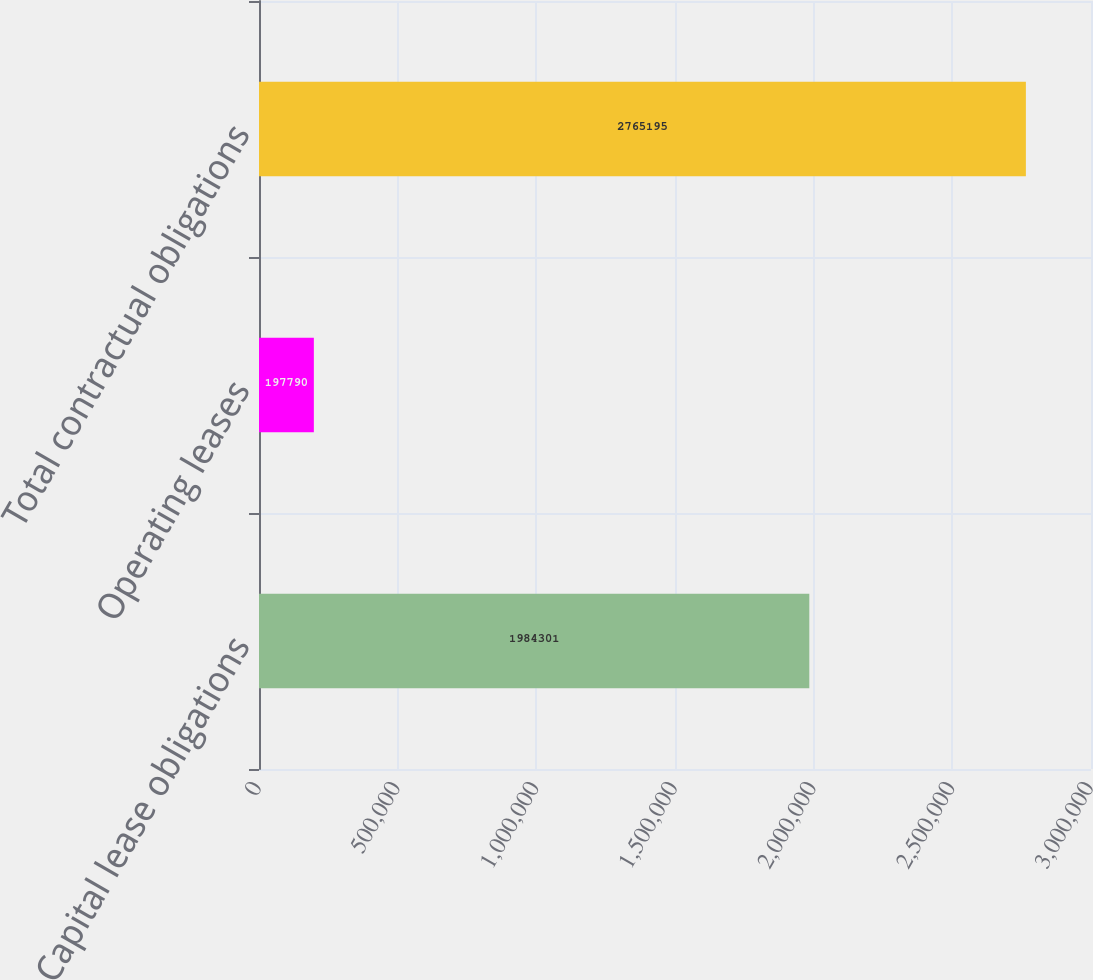Convert chart. <chart><loc_0><loc_0><loc_500><loc_500><bar_chart><fcel>Capital lease obligations<fcel>Operating leases<fcel>Total contractual obligations<nl><fcel>1.9843e+06<fcel>197790<fcel>2.7652e+06<nl></chart> 